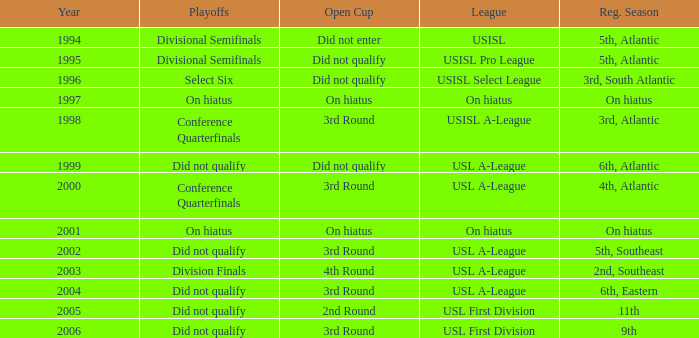What was the earliest year for the USISL Pro League? 1995.0. 